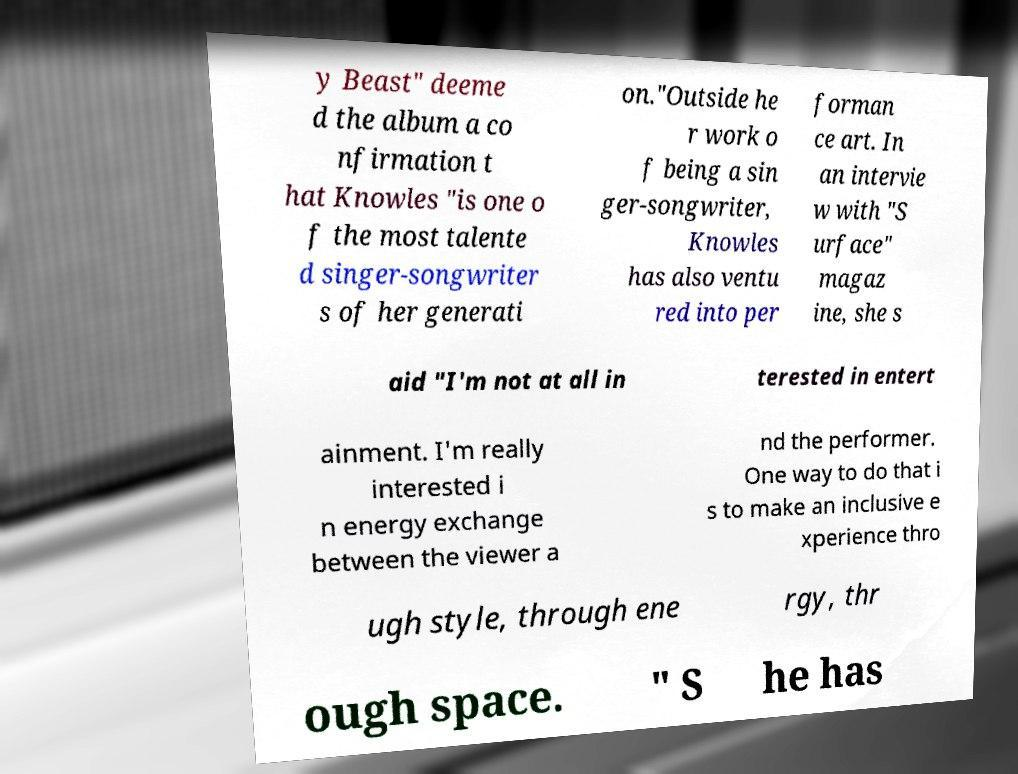Please identify and transcribe the text found in this image. y Beast" deeme d the album a co nfirmation t hat Knowles "is one o f the most talente d singer-songwriter s of her generati on."Outside he r work o f being a sin ger-songwriter, Knowles has also ventu red into per forman ce art. In an intervie w with "S urface" magaz ine, she s aid "I'm not at all in terested in entert ainment. I'm really interested i n energy exchange between the viewer a nd the performer. One way to do that i s to make an inclusive e xperience thro ugh style, through ene rgy, thr ough space. " S he has 